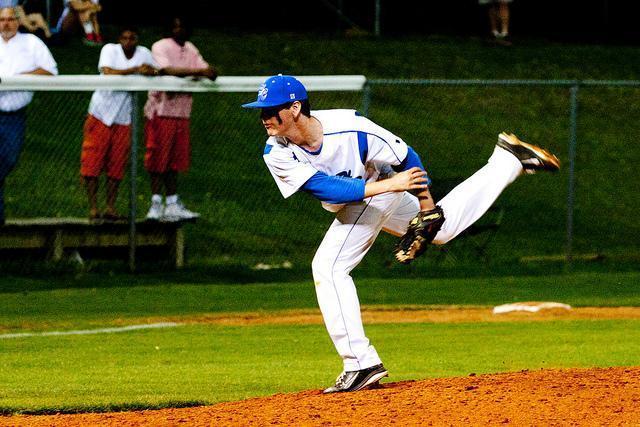How many pairs of red shorts do we see?
Give a very brief answer. 2. How many people can be seen?
Give a very brief answer. 4. How many giraffes are looking at the camera?
Give a very brief answer. 0. 